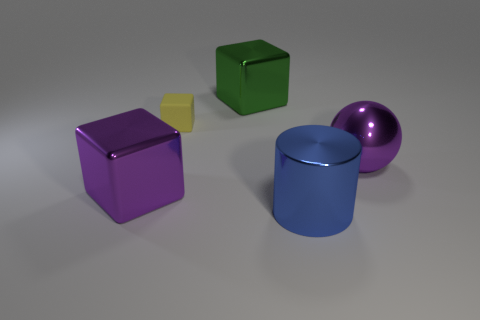There is a metallic thing that is both right of the green metallic object and behind the big blue thing; what is its shape?
Make the answer very short. Sphere. Are there an equal number of large green metallic cubes that are behind the big green object and big purple shiny spheres?
Provide a succinct answer. No. What number of things are large objects or big blocks that are behind the tiny thing?
Offer a terse response. 4. Are there any other metallic things of the same shape as the yellow thing?
Your answer should be compact. Yes. Is the number of matte things that are behind the big green shiny thing the same as the number of big shiny cubes in front of the small yellow matte cube?
Make the answer very short. No. Are there any other things that are the same size as the yellow rubber block?
Offer a terse response. No. What number of yellow things are either tiny objects or matte balls?
Keep it short and to the point. 1. What number of metallic objects are the same size as the purple block?
Your answer should be very brief. 3. What is the color of the metallic object that is both to the right of the green metallic object and in front of the purple ball?
Offer a terse response. Blue. Is the number of cubes that are behind the shiny sphere greater than the number of brown matte blocks?
Give a very brief answer. Yes. 